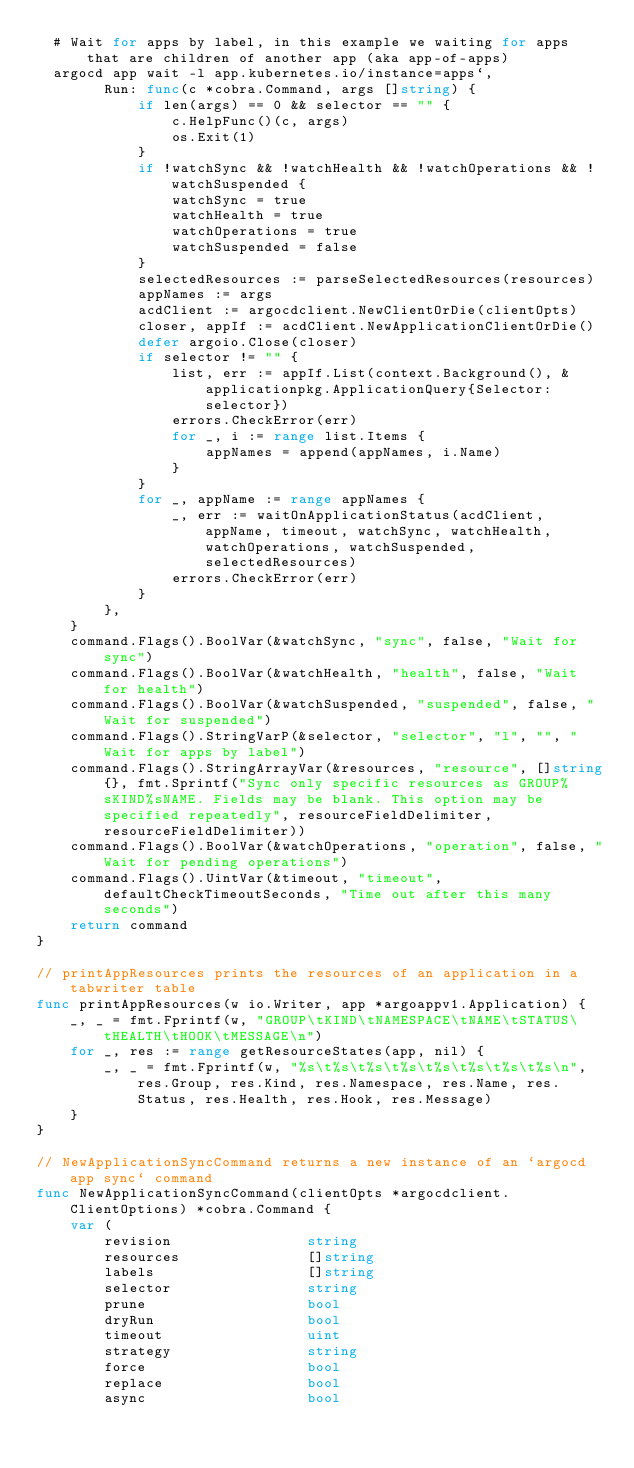Convert code to text. <code><loc_0><loc_0><loc_500><loc_500><_Go_>  # Wait for apps by label, in this example we waiting for apps that are children of another app (aka app-of-apps)
  argocd app wait -l app.kubernetes.io/instance=apps`,
		Run: func(c *cobra.Command, args []string) {
			if len(args) == 0 && selector == "" {
				c.HelpFunc()(c, args)
				os.Exit(1)
			}
			if !watchSync && !watchHealth && !watchOperations && !watchSuspended {
				watchSync = true
				watchHealth = true
				watchOperations = true
				watchSuspended = false
			}
			selectedResources := parseSelectedResources(resources)
			appNames := args
			acdClient := argocdclient.NewClientOrDie(clientOpts)
			closer, appIf := acdClient.NewApplicationClientOrDie()
			defer argoio.Close(closer)
			if selector != "" {
				list, err := appIf.List(context.Background(), &applicationpkg.ApplicationQuery{Selector: selector})
				errors.CheckError(err)
				for _, i := range list.Items {
					appNames = append(appNames, i.Name)
				}
			}
			for _, appName := range appNames {
				_, err := waitOnApplicationStatus(acdClient, appName, timeout, watchSync, watchHealth, watchOperations, watchSuspended, selectedResources)
				errors.CheckError(err)
			}
		},
	}
	command.Flags().BoolVar(&watchSync, "sync", false, "Wait for sync")
	command.Flags().BoolVar(&watchHealth, "health", false, "Wait for health")
	command.Flags().BoolVar(&watchSuspended, "suspended", false, "Wait for suspended")
	command.Flags().StringVarP(&selector, "selector", "l", "", "Wait for apps by label")
	command.Flags().StringArrayVar(&resources, "resource", []string{}, fmt.Sprintf("Sync only specific resources as GROUP%sKIND%sNAME. Fields may be blank. This option may be specified repeatedly", resourceFieldDelimiter, resourceFieldDelimiter))
	command.Flags().BoolVar(&watchOperations, "operation", false, "Wait for pending operations")
	command.Flags().UintVar(&timeout, "timeout", defaultCheckTimeoutSeconds, "Time out after this many seconds")
	return command
}

// printAppResources prints the resources of an application in a tabwriter table
func printAppResources(w io.Writer, app *argoappv1.Application) {
	_, _ = fmt.Fprintf(w, "GROUP\tKIND\tNAMESPACE\tNAME\tSTATUS\tHEALTH\tHOOK\tMESSAGE\n")
	for _, res := range getResourceStates(app, nil) {
		_, _ = fmt.Fprintf(w, "%s\t%s\t%s\t%s\t%s\t%s\t%s\t%s\n", res.Group, res.Kind, res.Namespace, res.Name, res.Status, res.Health, res.Hook, res.Message)
	}
}

// NewApplicationSyncCommand returns a new instance of an `argocd app sync` command
func NewApplicationSyncCommand(clientOpts *argocdclient.ClientOptions) *cobra.Command {
	var (
		revision                string
		resources               []string
		labels                  []string
		selector                string
		prune                   bool
		dryRun                  bool
		timeout                 uint
		strategy                string
		force                   bool
		replace                 bool
		async                   bool</code> 